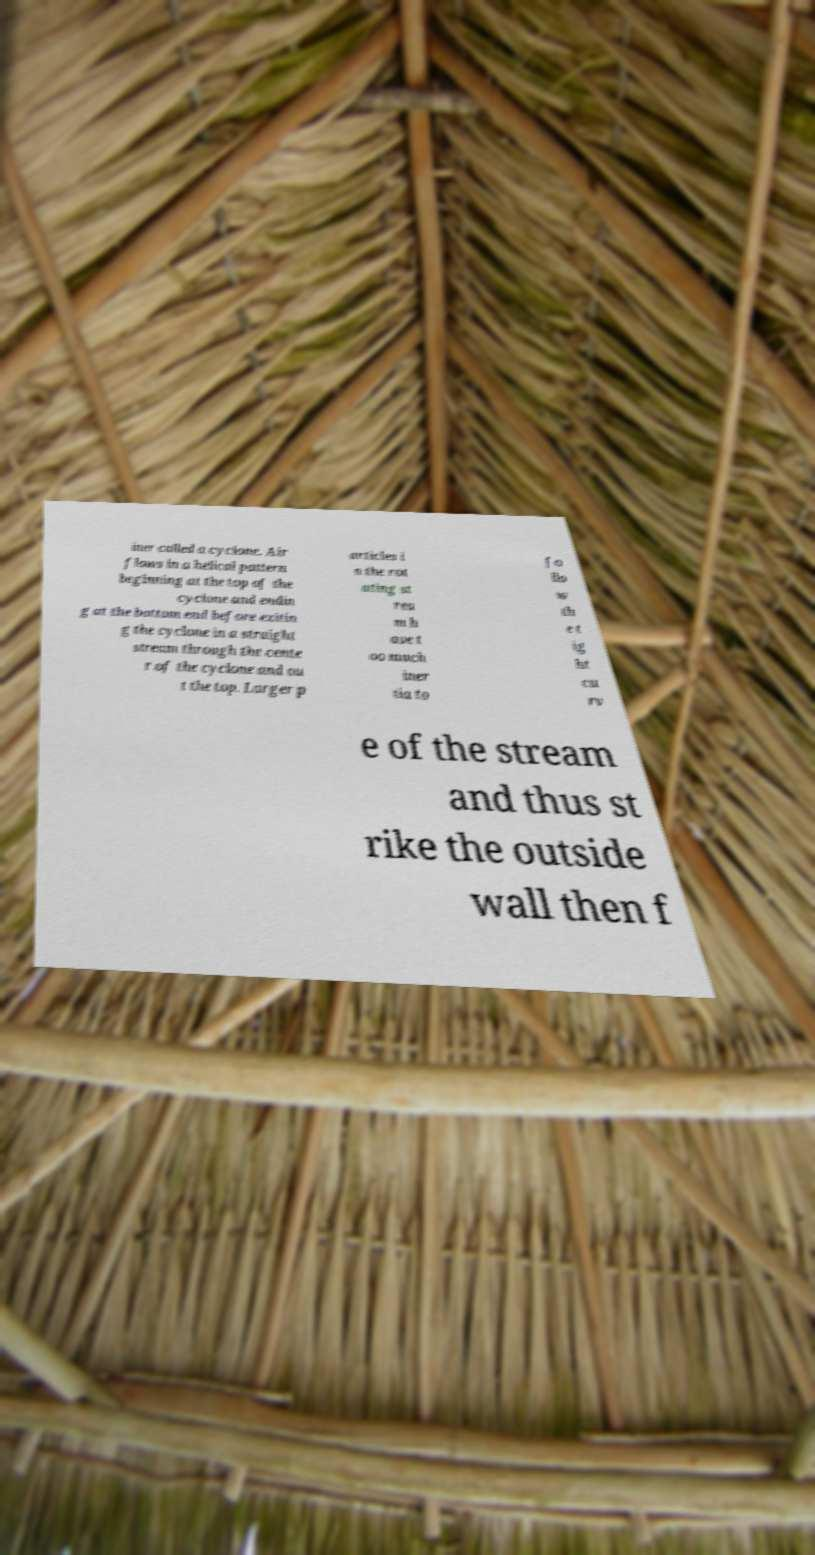Can you accurately transcribe the text from the provided image for me? iner called a cyclone. Air flows in a helical pattern beginning at the top of the cyclone and endin g at the bottom end before exitin g the cyclone in a straight stream through the cente r of the cyclone and ou t the top. Larger p articles i n the rot ating st rea m h ave t oo much iner tia to fo llo w th e t ig ht cu rv e of the stream and thus st rike the outside wall then f 